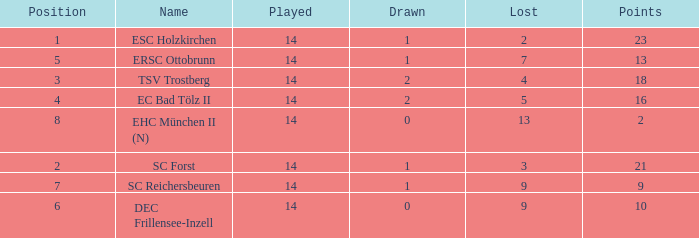How much Drawn has a Lost of 2, and Played smaller than 14? None. 